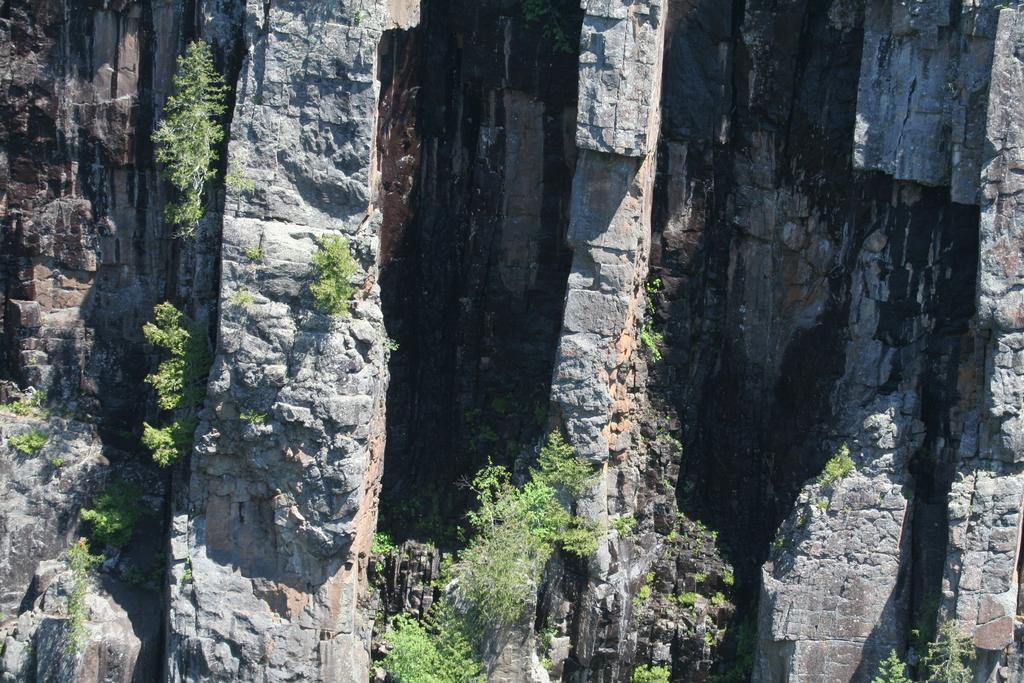What is the main feature in the image? There is a mountain in the image. Are there any other elements present in the image besides the mountain? Yes, there are plants around the mountain in the image. What type of loaf can be seen at the top of the mountain in the image? There is no loaf present in the image; it features a mountain with plants around it. How many frogs are visible on the mountain in the image? There are no frogs visible on the mountain in the image. 